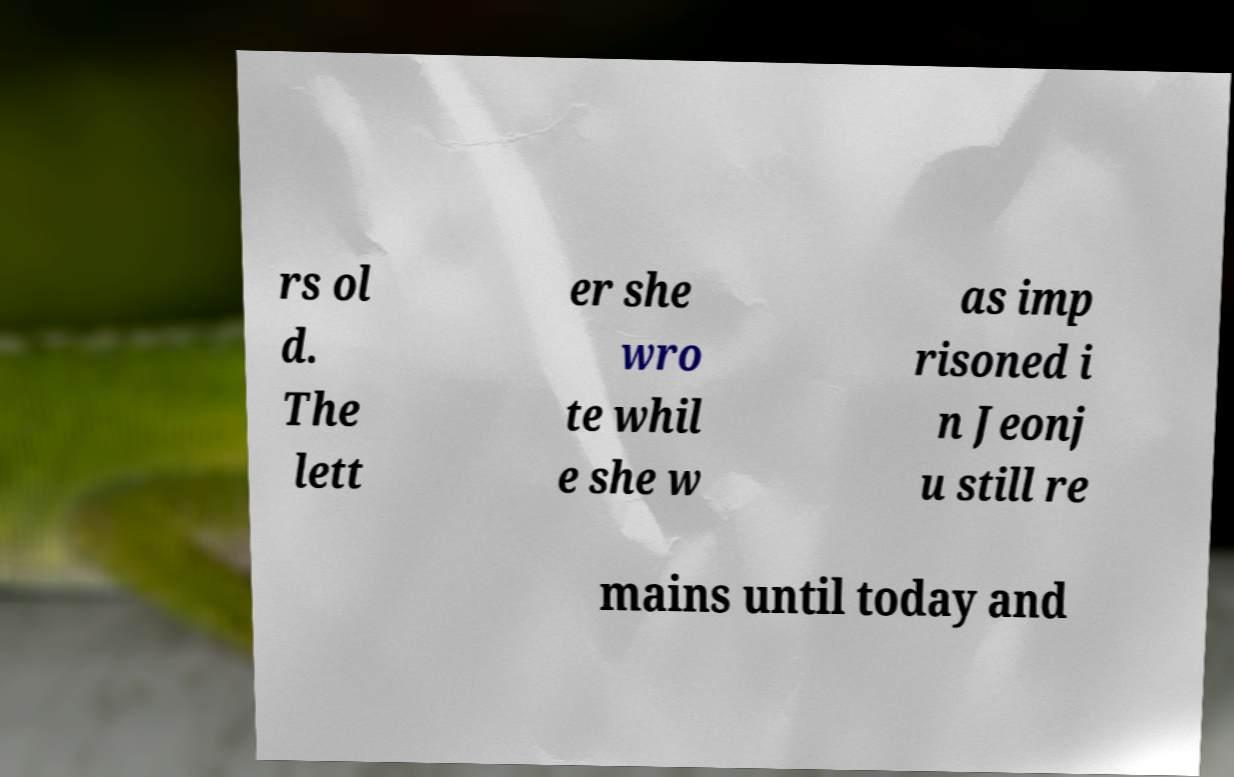For documentation purposes, I need the text within this image transcribed. Could you provide that? rs ol d. The lett er she wro te whil e she w as imp risoned i n Jeonj u still re mains until today and 